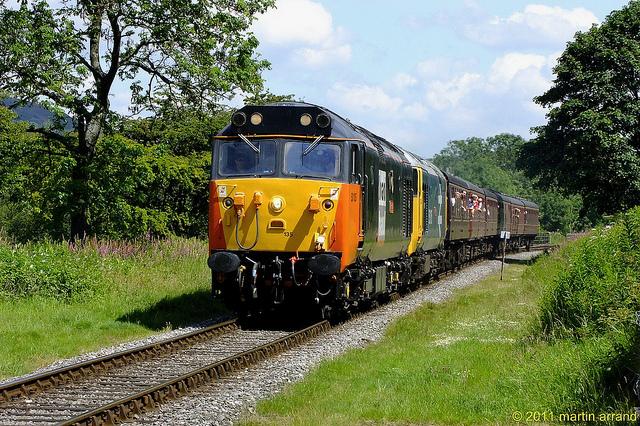Do you think this train is moving?
Short answer required. Yes. What is coming out of the train?
Quick response, please. Nothing. Does this appear to be a commercial train?
Write a very short answer. No. Is it raining?
Answer briefly. No. Is the train at the station?
Keep it brief. No. How many tracks on the ground?
Concise answer only. 2. Are there multiple train tracks?
Keep it brief. No. 